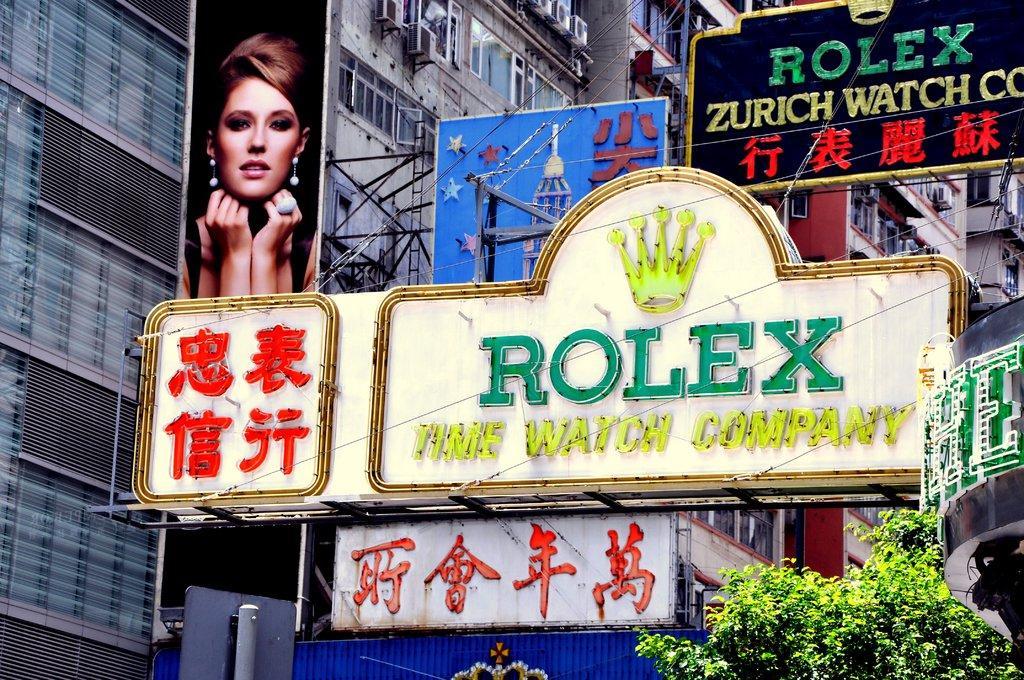Describe this image in one or two sentences. In the middle of the picture, we see the hoarding boards in white, blue and black color with some text written. On the right side, we see the board with some text written in green color. At the bottom, we see the trees and a board in blue color. We see a banner or a board in black color containing the image of the woman. She is smiling. In the background, we see the buildings, windows, wires and a pillar. 